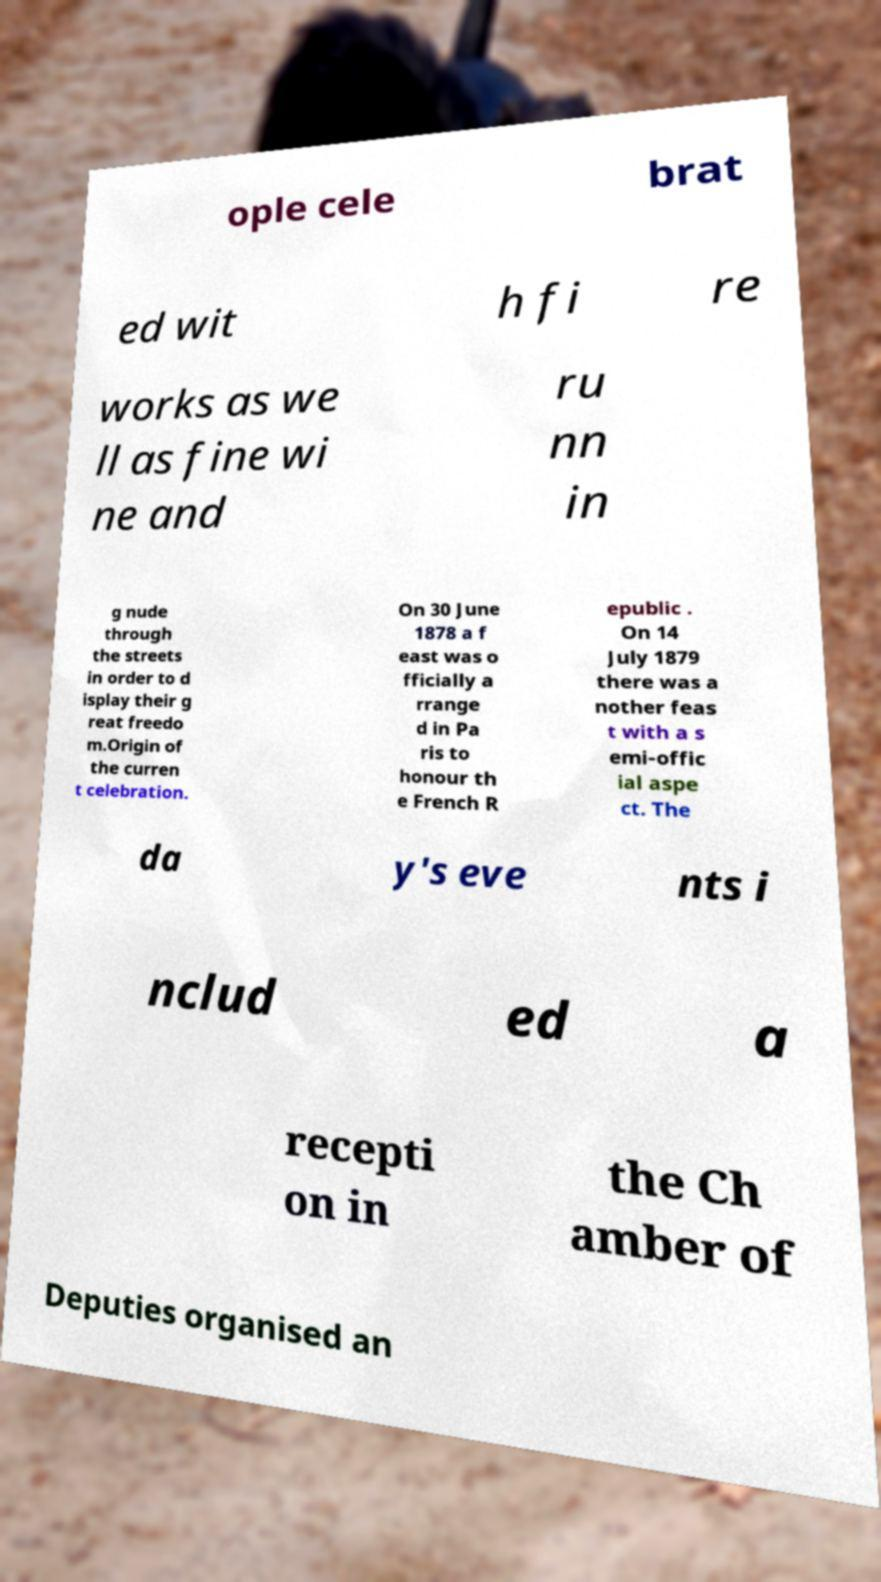Could you extract and type out the text from this image? ople cele brat ed wit h fi re works as we ll as fine wi ne and ru nn in g nude through the streets in order to d isplay their g reat freedo m.Origin of the curren t celebration. On 30 June 1878 a f east was o fficially a rrange d in Pa ris to honour th e French R epublic . On 14 July 1879 there was a nother feas t with a s emi-offic ial aspe ct. The da y's eve nts i nclud ed a recepti on in the Ch amber of Deputies organised an 